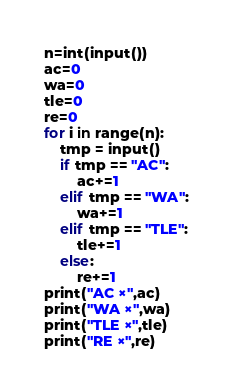Convert code to text. <code><loc_0><loc_0><loc_500><loc_500><_Python_>n=int(input())
ac=0
wa=0
tle=0
re=0
for i in range(n):
    tmp = input()
    if tmp == "AC":
        ac+=1
    elif tmp == "WA":
        wa+=1
    elif tmp == "TLE":
        tle+=1
    else:
        re+=1
print("AC ×",ac)
print("WA ×",wa)
print("TLE ×",tle)
print("RE ×",re)</code> 